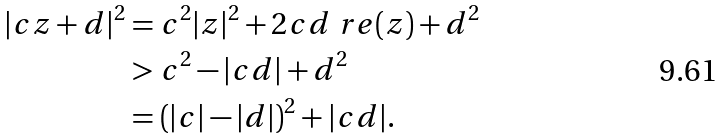Convert formula to latex. <formula><loc_0><loc_0><loc_500><loc_500>| c z + d | ^ { 2 } & = c ^ { 2 } | z | ^ { 2 } + 2 c d \ r e ( z ) + d ^ { 2 } \\ & > c ^ { 2 } - | c d | + d ^ { 2 } \\ & = ( | c | - | d | ) ^ { 2 } + | c d | .</formula> 